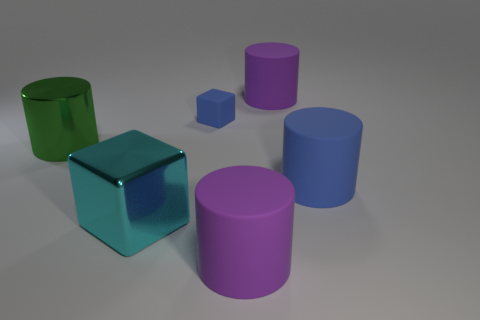The rubber object that is the same color as the tiny cube is what shape?
Offer a very short reply. Cylinder. Is there a small blue block in front of the blue matte cylinder that is right of the large purple thing in front of the green metallic object?
Your answer should be compact. No. There is a tiny thing to the right of the metallic block; is it the same color as the cylinder on the left side of the tiny blue rubber thing?
Offer a terse response. No. There is a blue thing that is the same size as the shiny block; what is it made of?
Keep it short and to the point. Rubber. There is a blue thing to the right of the purple rubber object in front of the blue object that is in front of the green shiny cylinder; what is its size?
Offer a terse response. Large. What number of other objects are the same material as the large cyan cube?
Offer a terse response. 1. How big is the matte thing that is behind the small blue matte thing?
Offer a very short reply. Large. What number of things are in front of the large green cylinder and on the right side of the cyan shiny thing?
Provide a short and direct response. 2. What is the material of the big purple cylinder in front of the large metal object that is behind the large metal cube?
Your response must be concise. Rubber. There is a large green object that is the same shape as the large blue matte object; what is its material?
Provide a succinct answer. Metal. 